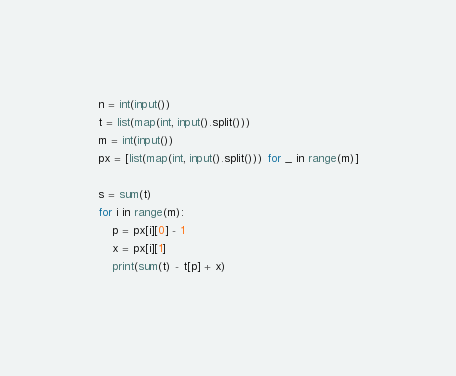<code> <loc_0><loc_0><loc_500><loc_500><_Python_>n = int(input())
t = list(map(int, input().split()))
m = int(input())
px = [list(map(int, input().split())) for _ in range(m)]

s = sum(t)
for i in range(m):
    p = px[i][0] - 1
    x = px[i][1]
    print(sum(t) - t[p] + x)
</code> 